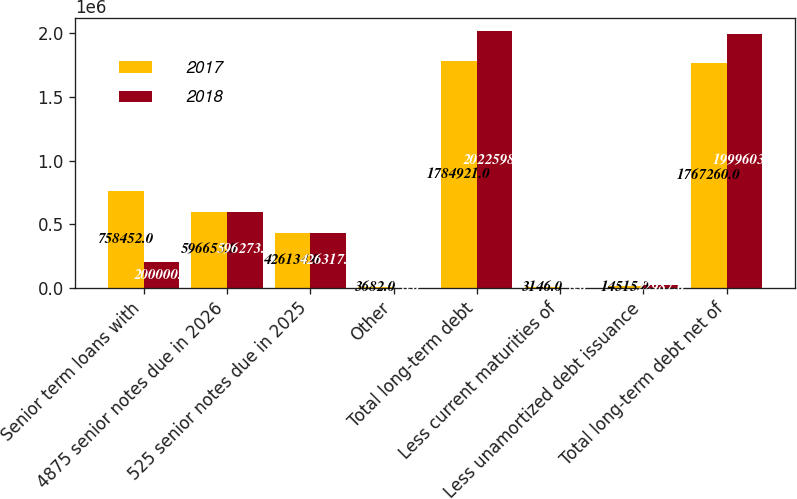<chart> <loc_0><loc_0><loc_500><loc_500><stacked_bar_chart><ecel><fcel>Senior term loans with<fcel>4875 senior notes due in 2026<fcel>525 senior notes due in 2025<fcel>Other<fcel>Total long-term debt<fcel>Less current maturities of<fcel>Less unamortized debt issuance<fcel>Total long-term debt net of<nl><fcel>2017<fcel>758452<fcel>596653<fcel>426134<fcel>3682<fcel>1.78492e+06<fcel>3146<fcel>14515<fcel>1.76726e+06<nl><fcel>2018<fcel>200000<fcel>596273<fcel>426317<fcel>8<fcel>2.0226e+06<fcel>8<fcel>22987<fcel>1.9996e+06<nl></chart> 